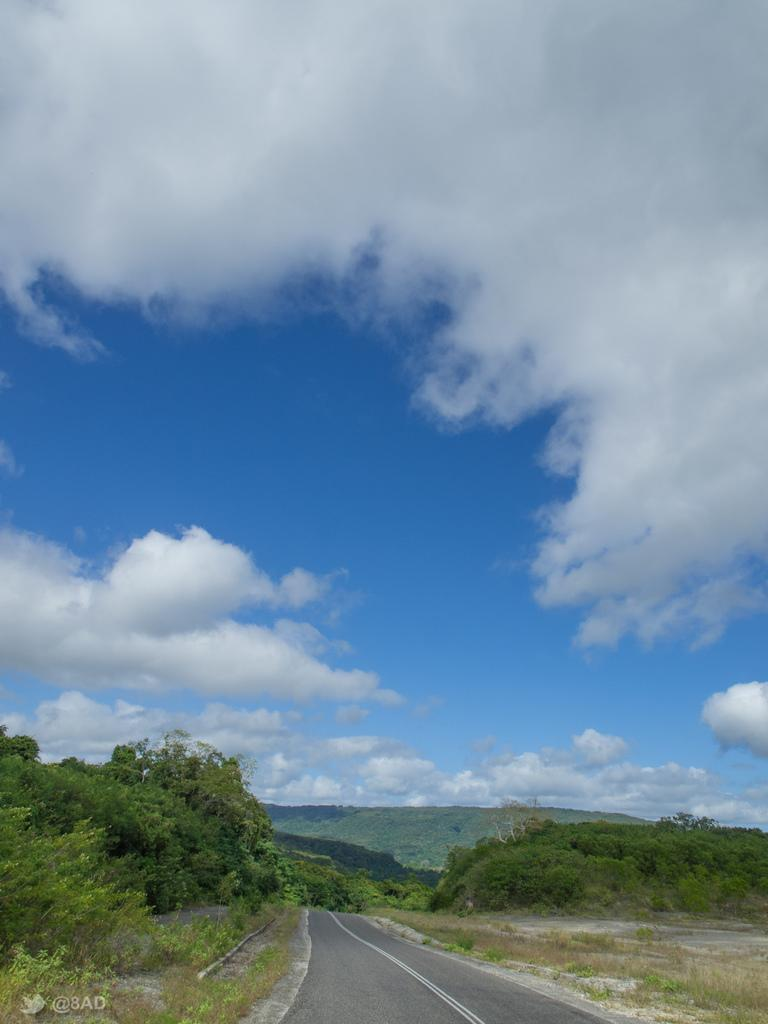What type of natural elements can be seen in the image? There are trees in the image. What man-made structure is visible in the image? There is a road in the image. What geographical feature is present in the image? There is a hill in the image. How would you describe the sky in the image? The sky is blue and cloudy. What type of clock is hanging from the trees in the image? There is no clock present in the image; it only features trees, a road, a hill, and a blue and cloudy sky. How many kittens can be seen playing on the hill in the image? There are no kittens present in the image; it only features trees, a road, a hill, and a blue and cloudy sky. 